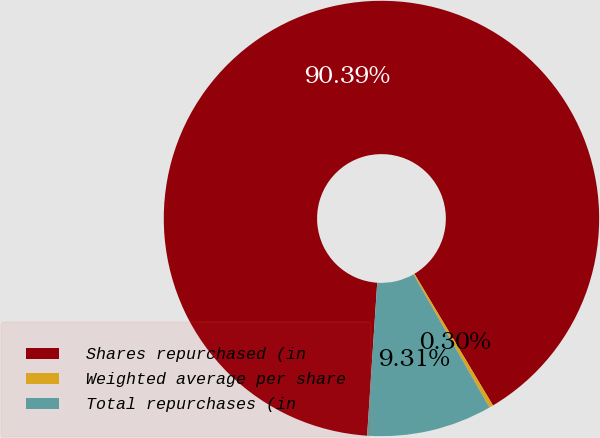Convert chart. <chart><loc_0><loc_0><loc_500><loc_500><pie_chart><fcel>Shares repurchased (in<fcel>Weighted average per share<fcel>Total repurchases (in<nl><fcel>90.38%<fcel>0.3%<fcel>9.31%<nl></chart> 